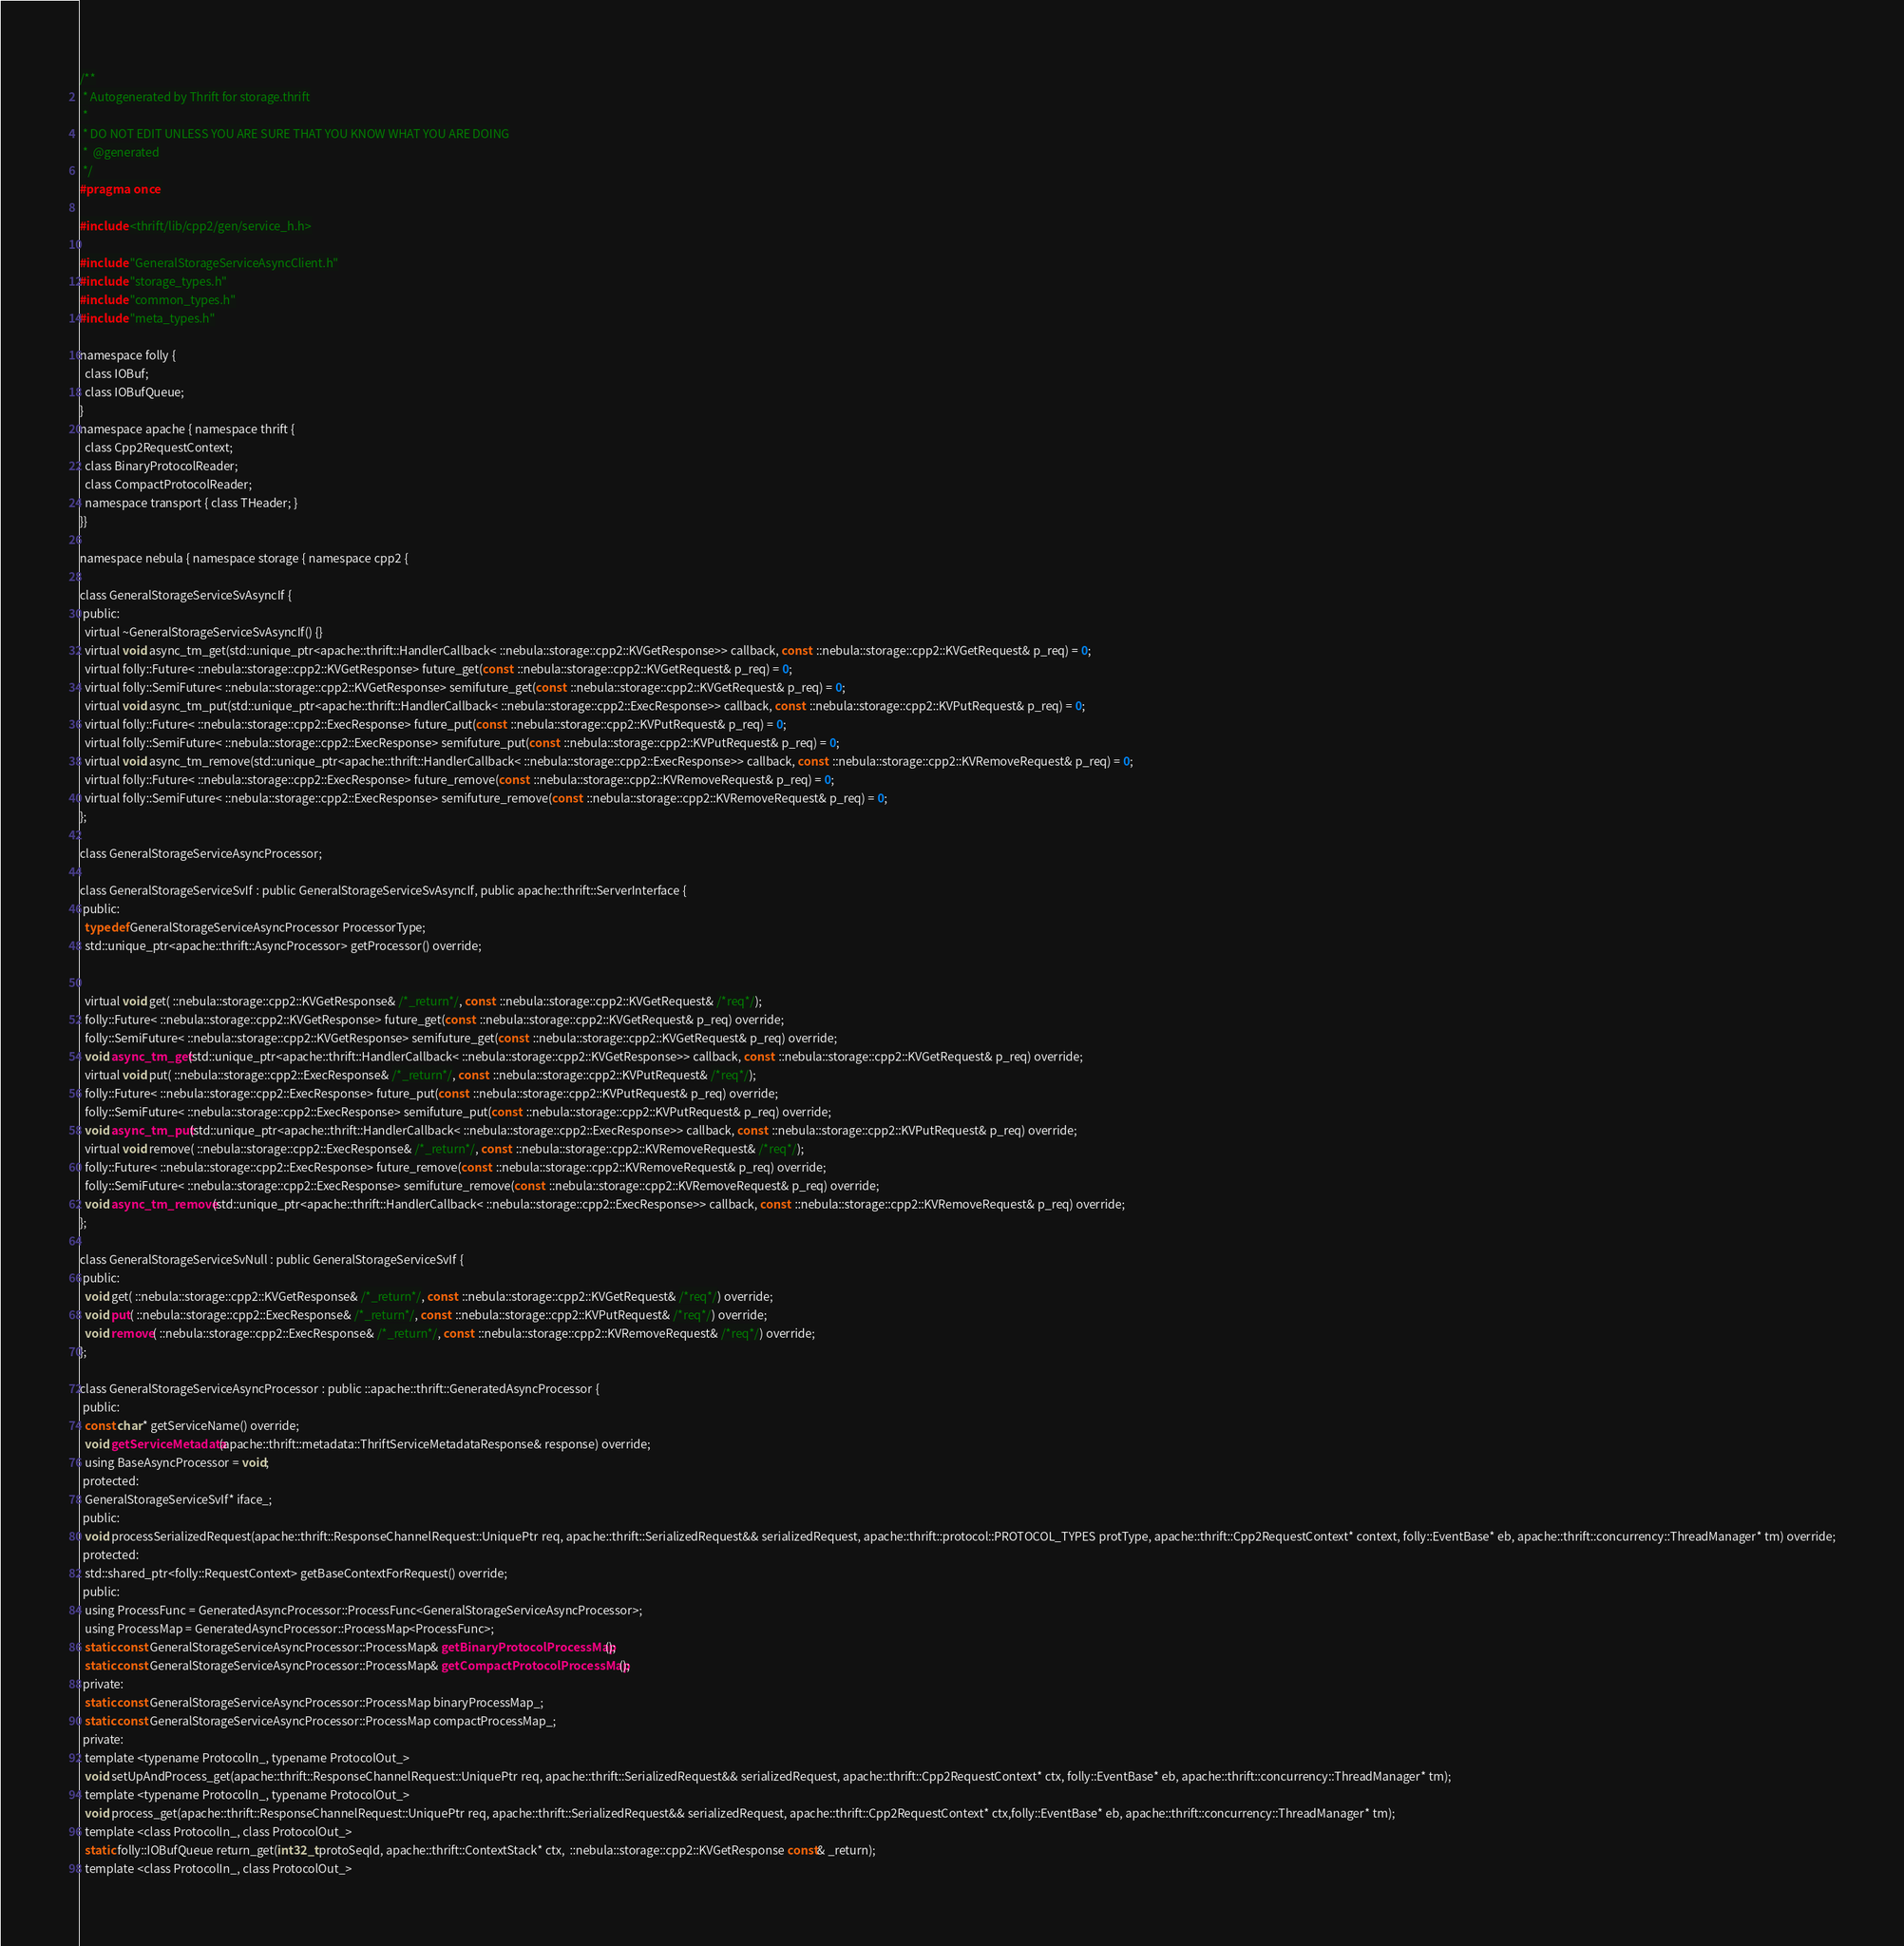<code> <loc_0><loc_0><loc_500><loc_500><_C_>/**
 * Autogenerated by Thrift for storage.thrift
 *
 * DO NOT EDIT UNLESS YOU ARE SURE THAT YOU KNOW WHAT YOU ARE DOING
 *  @generated
 */
#pragma once

#include <thrift/lib/cpp2/gen/service_h.h>

#include "GeneralStorageServiceAsyncClient.h"
#include "storage_types.h"
#include "common_types.h"
#include "meta_types.h"

namespace folly {
  class IOBuf;
  class IOBufQueue;
}
namespace apache { namespace thrift {
  class Cpp2RequestContext;
  class BinaryProtocolReader;
  class CompactProtocolReader;
  namespace transport { class THeader; }
}}

namespace nebula { namespace storage { namespace cpp2 {

class GeneralStorageServiceSvAsyncIf {
 public:
  virtual ~GeneralStorageServiceSvAsyncIf() {}
  virtual void async_tm_get(std::unique_ptr<apache::thrift::HandlerCallback< ::nebula::storage::cpp2::KVGetResponse>> callback, const  ::nebula::storage::cpp2::KVGetRequest& p_req) = 0;
  virtual folly::Future< ::nebula::storage::cpp2::KVGetResponse> future_get(const  ::nebula::storage::cpp2::KVGetRequest& p_req) = 0;
  virtual folly::SemiFuture< ::nebula::storage::cpp2::KVGetResponse> semifuture_get(const  ::nebula::storage::cpp2::KVGetRequest& p_req) = 0;
  virtual void async_tm_put(std::unique_ptr<apache::thrift::HandlerCallback< ::nebula::storage::cpp2::ExecResponse>> callback, const  ::nebula::storage::cpp2::KVPutRequest& p_req) = 0;
  virtual folly::Future< ::nebula::storage::cpp2::ExecResponse> future_put(const  ::nebula::storage::cpp2::KVPutRequest& p_req) = 0;
  virtual folly::SemiFuture< ::nebula::storage::cpp2::ExecResponse> semifuture_put(const  ::nebula::storage::cpp2::KVPutRequest& p_req) = 0;
  virtual void async_tm_remove(std::unique_ptr<apache::thrift::HandlerCallback< ::nebula::storage::cpp2::ExecResponse>> callback, const  ::nebula::storage::cpp2::KVRemoveRequest& p_req) = 0;
  virtual folly::Future< ::nebula::storage::cpp2::ExecResponse> future_remove(const  ::nebula::storage::cpp2::KVRemoveRequest& p_req) = 0;
  virtual folly::SemiFuture< ::nebula::storage::cpp2::ExecResponse> semifuture_remove(const  ::nebula::storage::cpp2::KVRemoveRequest& p_req) = 0;
};

class GeneralStorageServiceAsyncProcessor;

class GeneralStorageServiceSvIf : public GeneralStorageServiceSvAsyncIf, public apache::thrift::ServerInterface {
 public:
  typedef GeneralStorageServiceAsyncProcessor ProcessorType;
  std::unique_ptr<apache::thrift::AsyncProcessor> getProcessor() override;


  virtual void get( ::nebula::storage::cpp2::KVGetResponse& /*_return*/, const  ::nebula::storage::cpp2::KVGetRequest& /*req*/);
  folly::Future< ::nebula::storage::cpp2::KVGetResponse> future_get(const  ::nebula::storage::cpp2::KVGetRequest& p_req) override;
  folly::SemiFuture< ::nebula::storage::cpp2::KVGetResponse> semifuture_get(const  ::nebula::storage::cpp2::KVGetRequest& p_req) override;
  void async_tm_get(std::unique_ptr<apache::thrift::HandlerCallback< ::nebula::storage::cpp2::KVGetResponse>> callback, const  ::nebula::storage::cpp2::KVGetRequest& p_req) override;
  virtual void put( ::nebula::storage::cpp2::ExecResponse& /*_return*/, const  ::nebula::storage::cpp2::KVPutRequest& /*req*/);
  folly::Future< ::nebula::storage::cpp2::ExecResponse> future_put(const  ::nebula::storage::cpp2::KVPutRequest& p_req) override;
  folly::SemiFuture< ::nebula::storage::cpp2::ExecResponse> semifuture_put(const  ::nebula::storage::cpp2::KVPutRequest& p_req) override;
  void async_tm_put(std::unique_ptr<apache::thrift::HandlerCallback< ::nebula::storage::cpp2::ExecResponse>> callback, const  ::nebula::storage::cpp2::KVPutRequest& p_req) override;
  virtual void remove( ::nebula::storage::cpp2::ExecResponse& /*_return*/, const  ::nebula::storage::cpp2::KVRemoveRequest& /*req*/);
  folly::Future< ::nebula::storage::cpp2::ExecResponse> future_remove(const  ::nebula::storage::cpp2::KVRemoveRequest& p_req) override;
  folly::SemiFuture< ::nebula::storage::cpp2::ExecResponse> semifuture_remove(const  ::nebula::storage::cpp2::KVRemoveRequest& p_req) override;
  void async_tm_remove(std::unique_ptr<apache::thrift::HandlerCallback< ::nebula::storage::cpp2::ExecResponse>> callback, const  ::nebula::storage::cpp2::KVRemoveRequest& p_req) override;
};

class GeneralStorageServiceSvNull : public GeneralStorageServiceSvIf {
 public:
  void get( ::nebula::storage::cpp2::KVGetResponse& /*_return*/, const  ::nebula::storage::cpp2::KVGetRequest& /*req*/) override;
  void put( ::nebula::storage::cpp2::ExecResponse& /*_return*/, const  ::nebula::storage::cpp2::KVPutRequest& /*req*/) override;
  void remove( ::nebula::storage::cpp2::ExecResponse& /*_return*/, const  ::nebula::storage::cpp2::KVRemoveRequest& /*req*/) override;
};

class GeneralStorageServiceAsyncProcessor : public ::apache::thrift::GeneratedAsyncProcessor {
 public:
  const char* getServiceName() override;
  void getServiceMetadata(apache::thrift::metadata::ThriftServiceMetadataResponse& response) override;
  using BaseAsyncProcessor = void;
 protected:
  GeneralStorageServiceSvIf* iface_;
 public:
  void processSerializedRequest(apache::thrift::ResponseChannelRequest::UniquePtr req, apache::thrift::SerializedRequest&& serializedRequest, apache::thrift::protocol::PROTOCOL_TYPES protType, apache::thrift::Cpp2RequestContext* context, folly::EventBase* eb, apache::thrift::concurrency::ThreadManager* tm) override;
 protected:
  std::shared_ptr<folly::RequestContext> getBaseContextForRequest() override;
 public:
  using ProcessFunc = GeneratedAsyncProcessor::ProcessFunc<GeneralStorageServiceAsyncProcessor>;
  using ProcessMap = GeneratedAsyncProcessor::ProcessMap<ProcessFunc>;
  static const GeneralStorageServiceAsyncProcessor::ProcessMap& getBinaryProtocolProcessMap();
  static const GeneralStorageServiceAsyncProcessor::ProcessMap& getCompactProtocolProcessMap();
 private:
  static const GeneralStorageServiceAsyncProcessor::ProcessMap binaryProcessMap_;
  static const GeneralStorageServiceAsyncProcessor::ProcessMap compactProcessMap_;
 private:
  template <typename ProtocolIn_, typename ProtocolOut_>
  void setUpAndProcess_get(apache::thrift::ResponseChannelRequest::UniquePtr req, apache::thrift::SerializedRequest&& serializedRequest, apache::thrift::Cpp2RequestContext* ctx, folly::EventBase* eb, apache::thrift::concurrency::ThreadManager* tm);
  template <typename ProtocolIn_, typename ProtocolOut_>
  void process_get(apache::thrift::ResponseChannelRequest::UniquePtr req, apache::thrift::SerializedRequest&& serializedRequest, apache::thrift::Cpp2RequestContext* ctx,folly::EventBase* eb, apache::thrift::concurrency::ThreadManager* tm);
  template <class ProtocolIn_, class ProtocolOut_>
  static folly::IOBufQueue return_get(int32_t protoSeqId, apache::thrift::ContextStack* ctx,  ::nebula::storage::cpp2::KVGetResponse const& _return);
  template <class ProtocolIn_, class ProtocolOut_></code> 